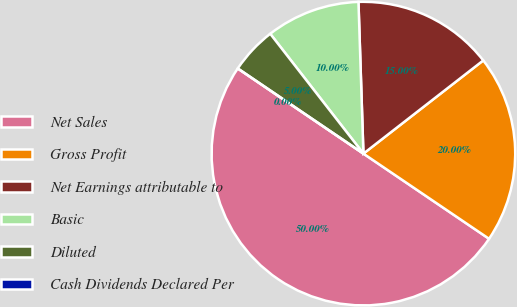Convert chart to OTSL. <chart><loc_0><loc_0><loc_500><loc_500><pie_chart><fcel>Net Sales<fcel>Gross Profit<fcel>Net Earnings attributable to<fcel>Basic<fcel>Diluted<fcel>Cash Dividends Declared Per<nl><fcel>50.0%<fcel>20.0%<fcel>15.0%<fcel>10.0%<fcel>5.0%<fcel>0.0%<nl></chart> 